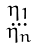Convert formula to latex. <formula><loc_0><loc_0><loc_500><loc_500>\begin{smallmatrix} \eta _ { 1 } \\ \dots \\ \eta _ { n } \end{smallmatrix}</formula> 